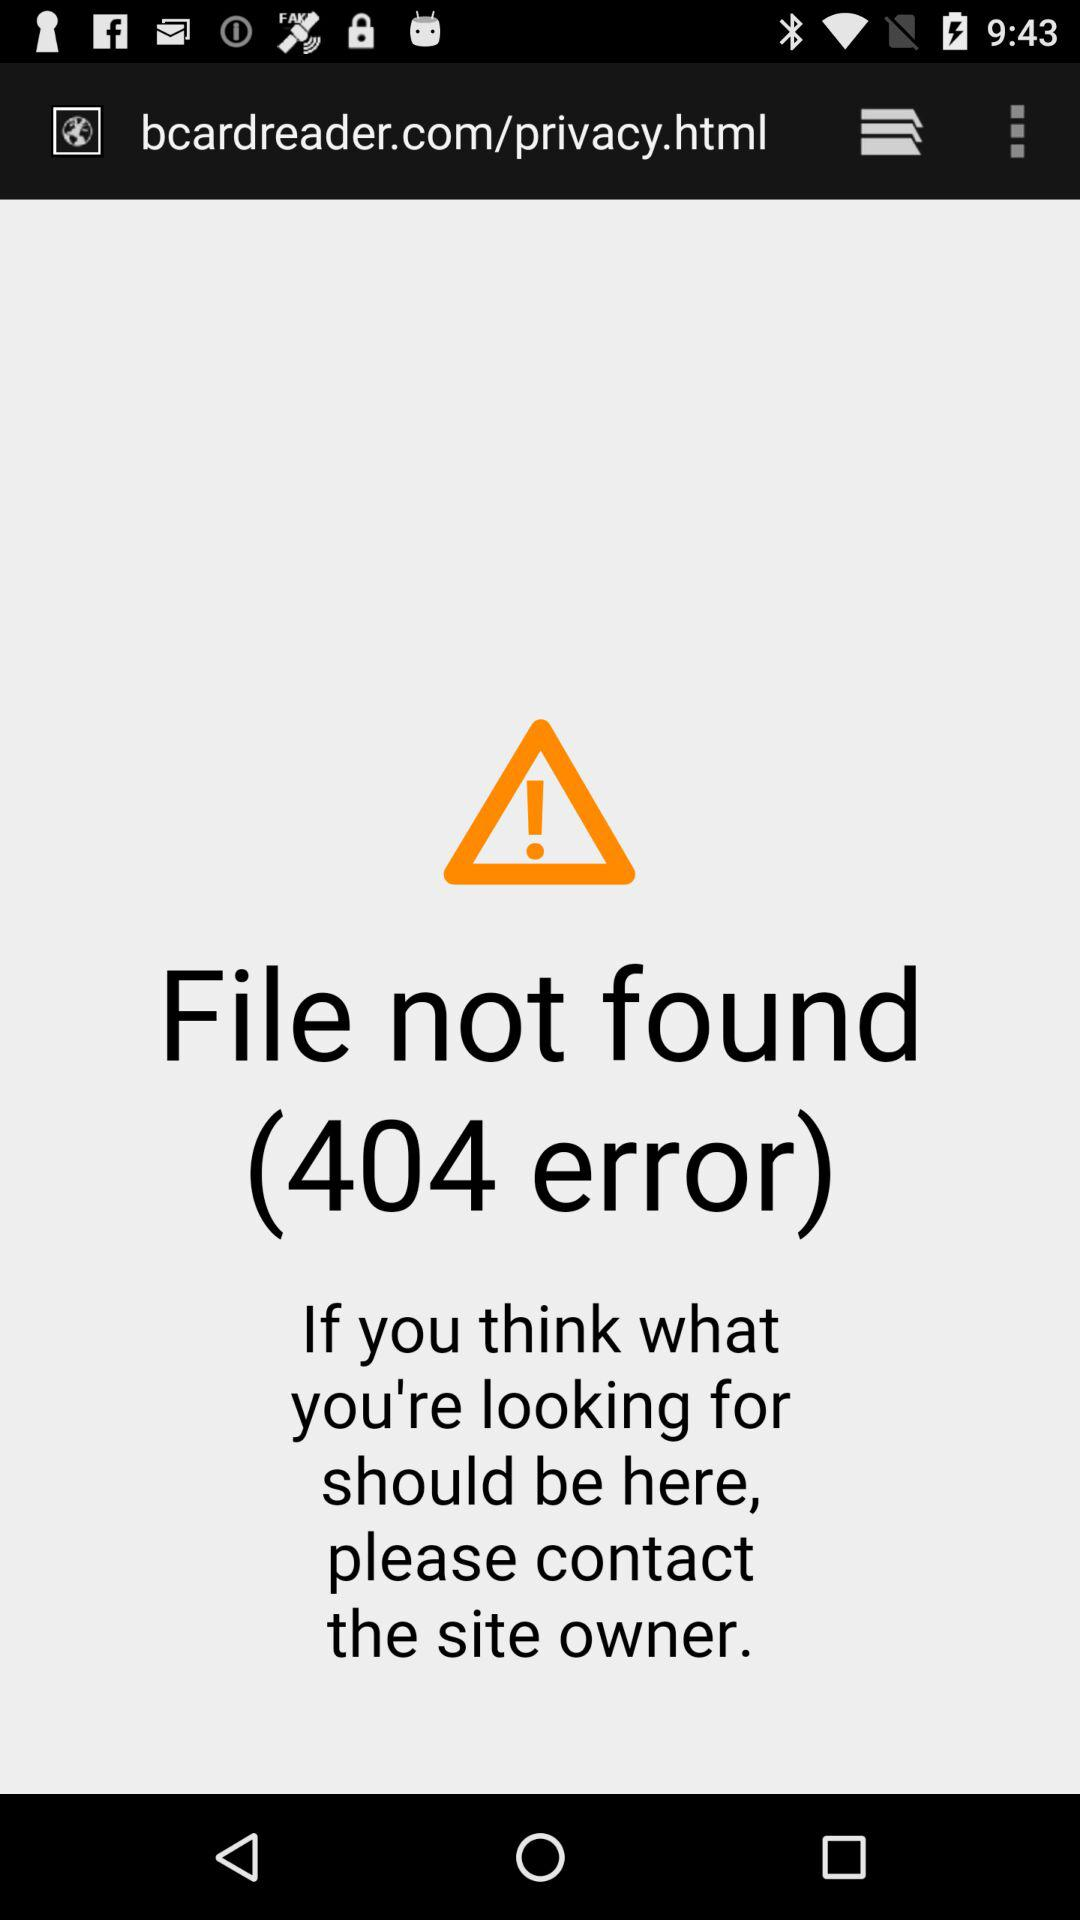What's the error code? The error code is 404. 